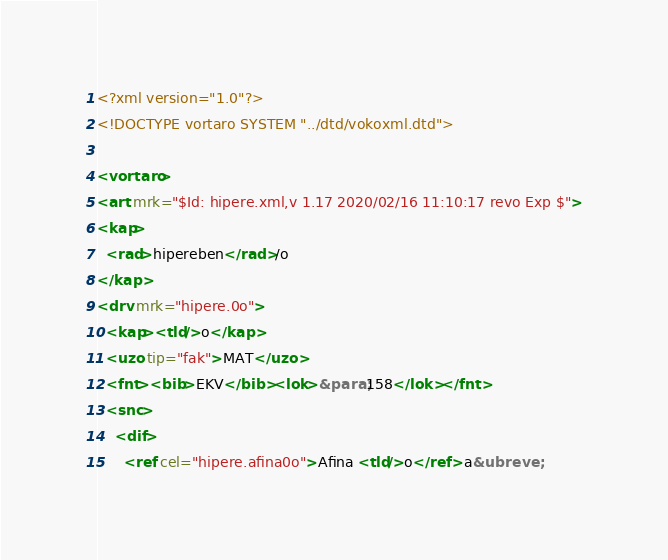Convert code to text. <code><loc_0><loc_0><loc_500><loc_500><_XML_><?xml version="1.0"?>
<!DOCTYPE vortaro SYSTEM "../dtd/vokoxml.dtd">

<vortaro>
<art mrk="$Id: hipere.xml,v 1.17 2020/02/16 11:10:17 revo Exp $">
<kap>
  <rad>hipereben</rad>/o
</kap>
<drv mrk="hipere.0o">
  <kap><tld/>o</kap>
  <uzo tip="fak">MAT</uzo>
  <fnt><bib>EKV</bib><lok>&para;158</lok></fnt>
  <snc>
    <dif>
      <ref cel="hipere.afina0o">Afina <tld/>o</ref> a&ubreve;</code> 